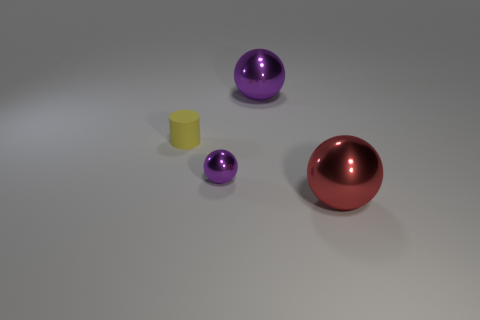Add 3 purple balls. How many objects exist? 7 Subtract all small balls. How many balls are left? 2 Subtract all purple balls. How many balls are left? 1 Subtract all tiny metal things. Subtract all small red cylinders. How many objects are left? 3 Add 3 big purple objects. How many big purple objects are left? 4 Add 1 small matte objects. How many small matte objects exist? 2 Subtract 0 purple blocks. How many objects are left? 4 Subtract all cylinders. How many objects are left? 3 Subtract 3 spheres. How many spheres are left? 0 Subtract all green spheres. Subtract all gray cylinders. How many spheres are left? 3 